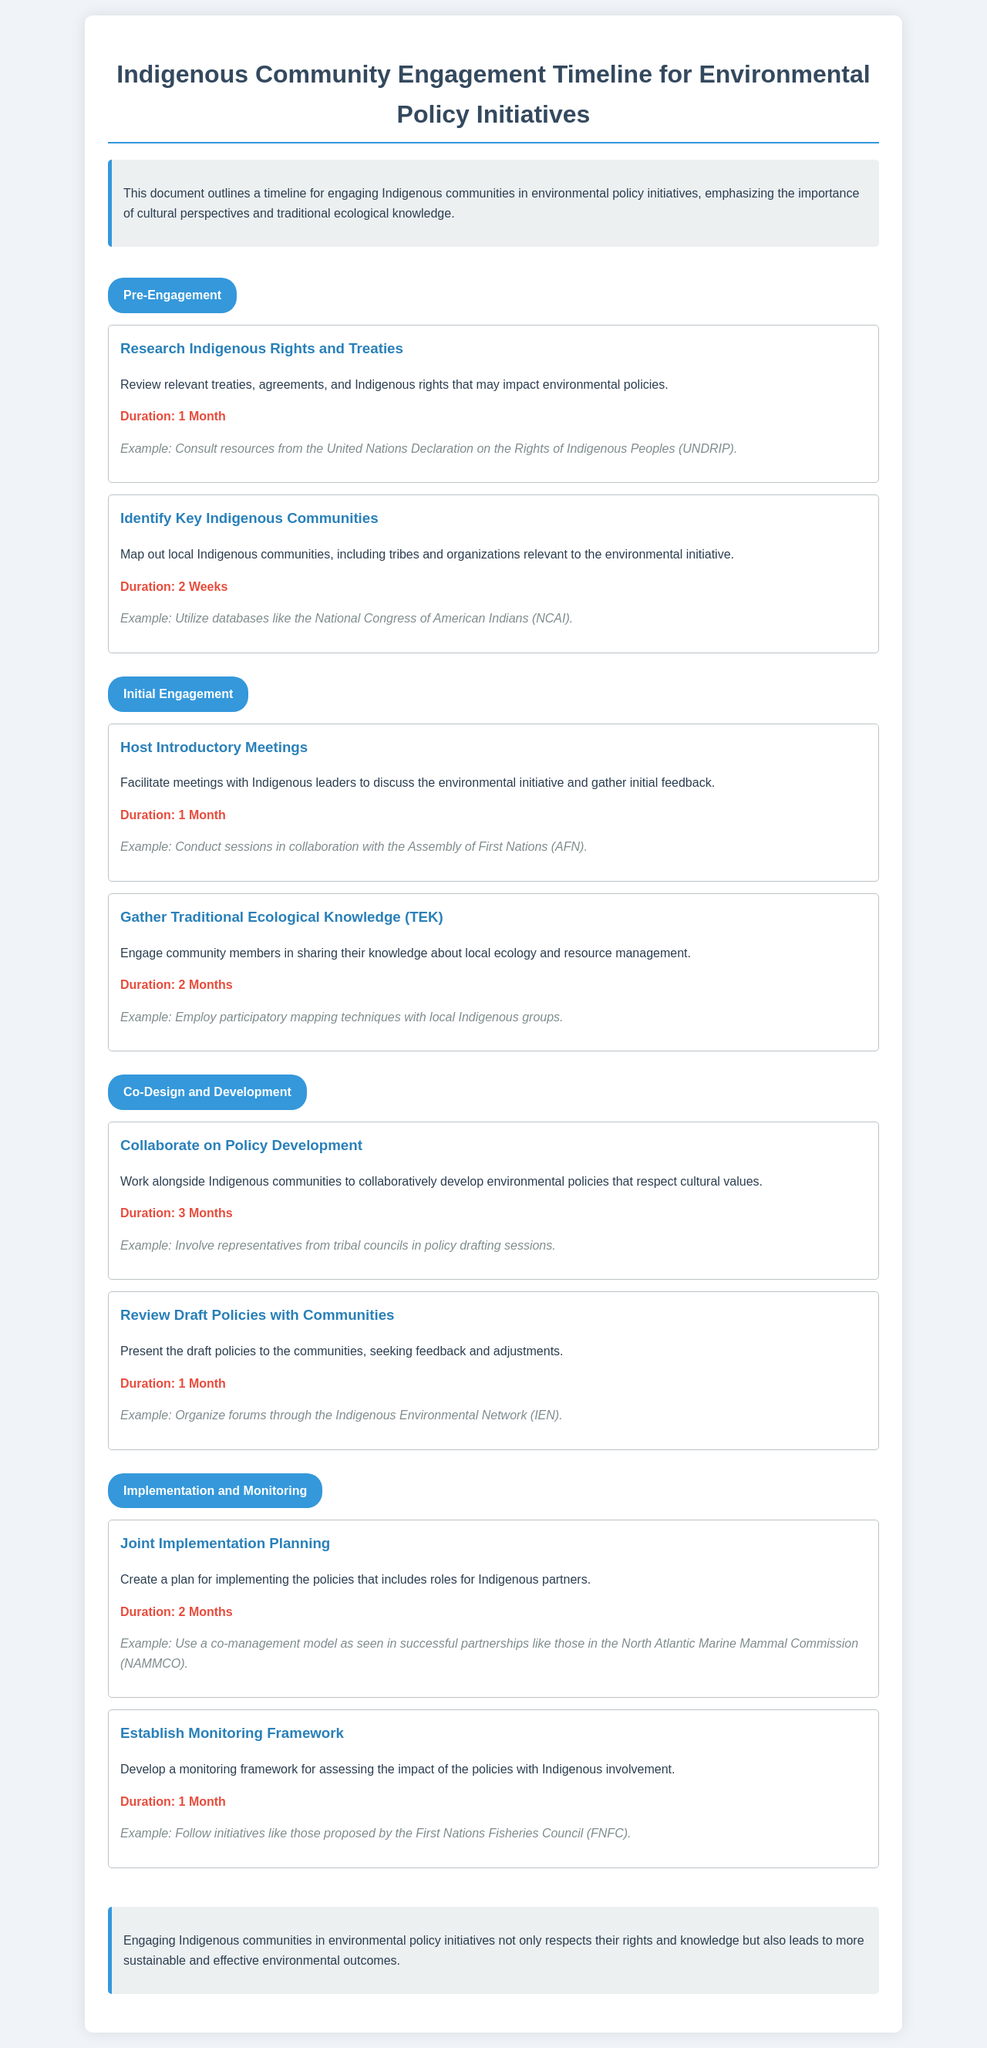what is the duration for the "Research Indigenous Rights and Treaties"? The duration for this activity is stated in the document as one month.
Answer: 1 Month how many weeks are allocated to identify key Indigenous communities? The document specifies that this activity takes two weeks.
Answer: 2 Weeks what is the main goal of the "Gather Traditional Ecological Knowledge (TEK)" activity? This activity aims to engage community members in sharing their knowledge about local ecology and resource management.
Answer: Share knowledge which organization is mentioned as a resource for hosting introductory meetings? The Assembly of First Nations (AFN) is referenced for facilitating these meetings.
Answer: Assembly of First Nations (AFN) what is the overall purpose of the document? The document outlines a timeline for engaging Indigenous communities in environmental policy initiatives.
Answer: Engagement timeline how long is the "Collaborate on Policy Development" phase? The document states that this phase lasts for three months.
Answer: 3 Months what is a suggested example for establishing a monitoring framework? The document cites the First Nations Fisheries Council (FNFC) as an example initiative.
Answer: First Nations Fisheries Council (FNFC) what unique strategy is mentioned for implementation planning? The co-management model is highlighted as a strategy for joint implementation planning.
Answer: Co-management model 